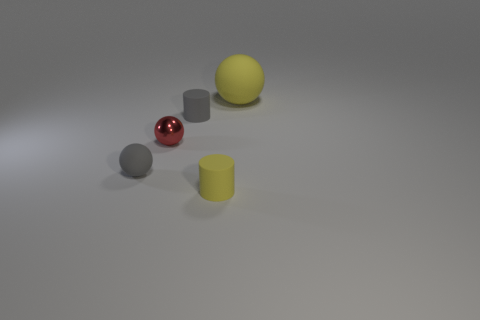Subtract all large yellow spheres. How many spheres are left? 2 Subtract all yellow balls. How many balls are left? 2 Subtract all cyan cubes. How many cyan balls are left? 0 Subtract 2 spheres. How many spheres are left? 1 Subtract all brown balls. Subtract all green blocks. How many balls are left? 3 Subtract all big cyan things. Subtract all rubber things. How many objects are left? 1 Add 2 matte balls. How many matte balls are left? 4 Add 5 cyan spheres. How many cyan spheres exist? 5 Add 1 gray rubber things. How many objects exist? 6 Subtract 1 yellow balls. How many objects are left? 4 